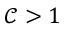<formula> <loc_0><loc_0><loc_500><loc_500>\mathcal { C } > 1</formula> 